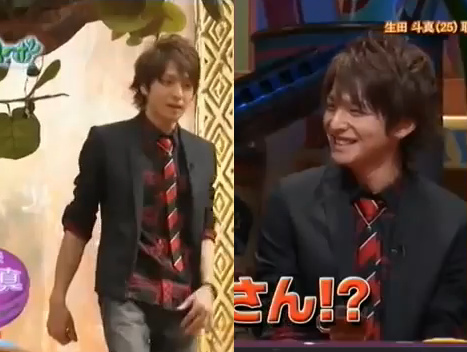Are there either numbers or cars in this image? No, there are neither numbers nor cars in the image. 